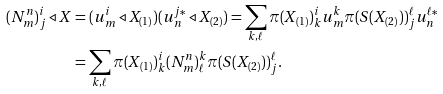Convert formula to latex. <formula><loc_0><loc_0><loc_500><loc_500>( N _ { m } ^ { n } ) _ { j } ^ { i } \triangleleft X & = ( u _ { m } ^ { i } \triangleleft X _ { ( 1 ) } ) ( u _ { n } ^ { j * } \triangleleft X _ { ( 2 ) } ) = \sum _ { k , \ell } \pi ( X _ { ( 1 ) } ) _ { k } ^ { i } u _ { m } ^ { k } \pi ( S ( X _ { ( 2 ) } ) ) _ { j } ^ { \ell } u _ { n } ^ { \ell * } \\ & = \sum _ { k , \ell } \pi ( X _ { ( 1 ) } ) _ { k } ^ { i } ( N _ { m } ^ { n } ) _ { \ell } ^ { k } \pi ( S ( X _ { ( 2 ) } ) ) _ { j } ^ { \ell } .</formula> 